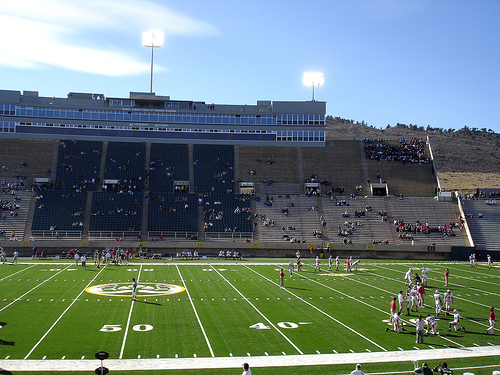<image>
Can you confirm if the football field is in the stadium bleachers? Yes. The football field is contained within or inside the stadium bleachers, showing a containment relationship. 